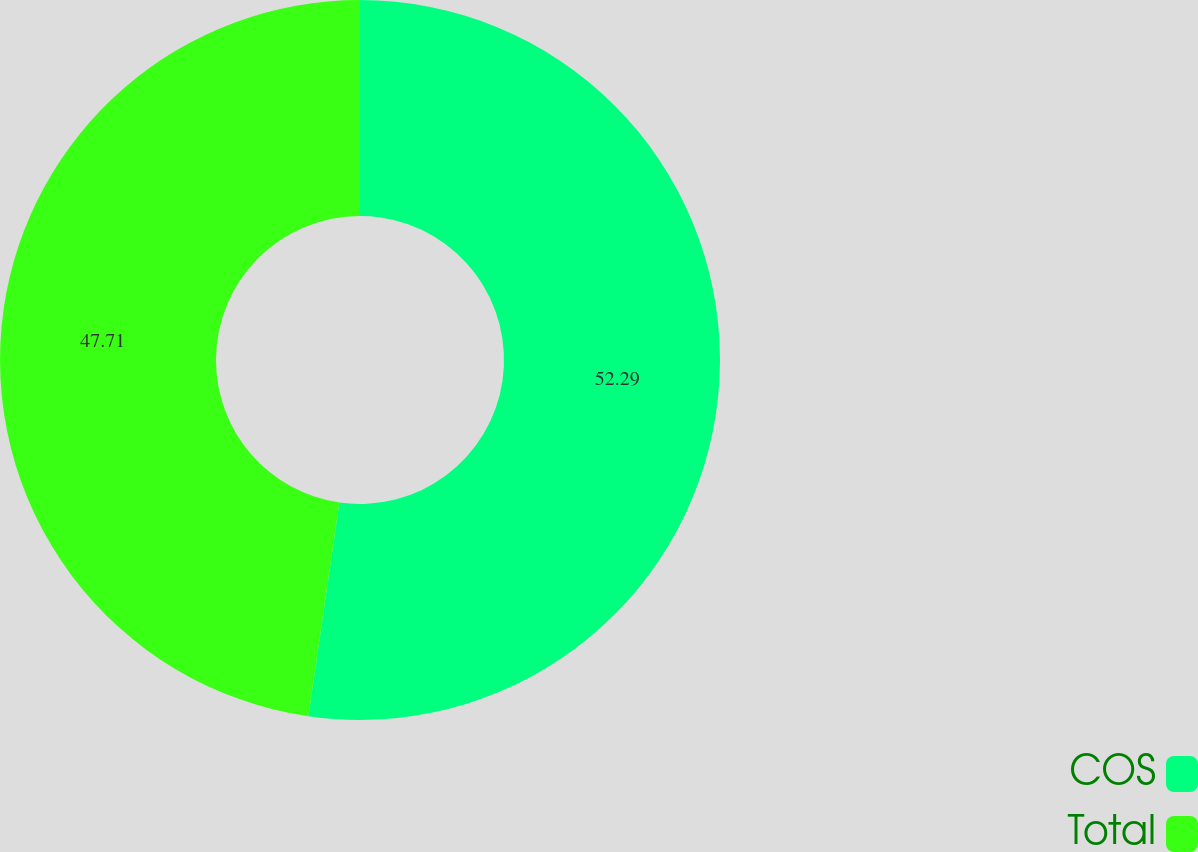Convert chart to OTSL. <chart><loc_0><loc_0><loc_500><loc_500><pie_chart><fcel>COS<fcel>Total<nl><fcel>52.29%<fcel>47.71%<nl></chart> 